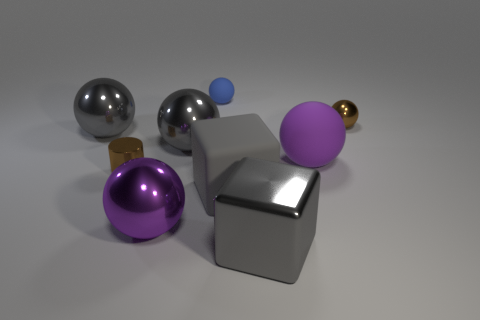Subtract all gray balls. How many balls are left? 4 Subtract 2 spheres. How many spheres are left? 4 Subtract all blue matte spheres. How many spheres are left? 5 Subtract all purple balls. Subtract all cyan cylinders. How many balls are left? 4 Add 1 small blue cylinders. How many objects exist? 10 Subtract all blocks. How many objects are left? 7 Add 1 tiny cyan metallic objects. How many tiny cyan metallic objects exist? 1 Subtract 0 red cylinders. How many objects are left? 9 Subtract all large matte balls. Subtract all big rubber spheres. How many objects are left? 7 Add 1 metallic spheres. How many metallic spheres are left? 5 